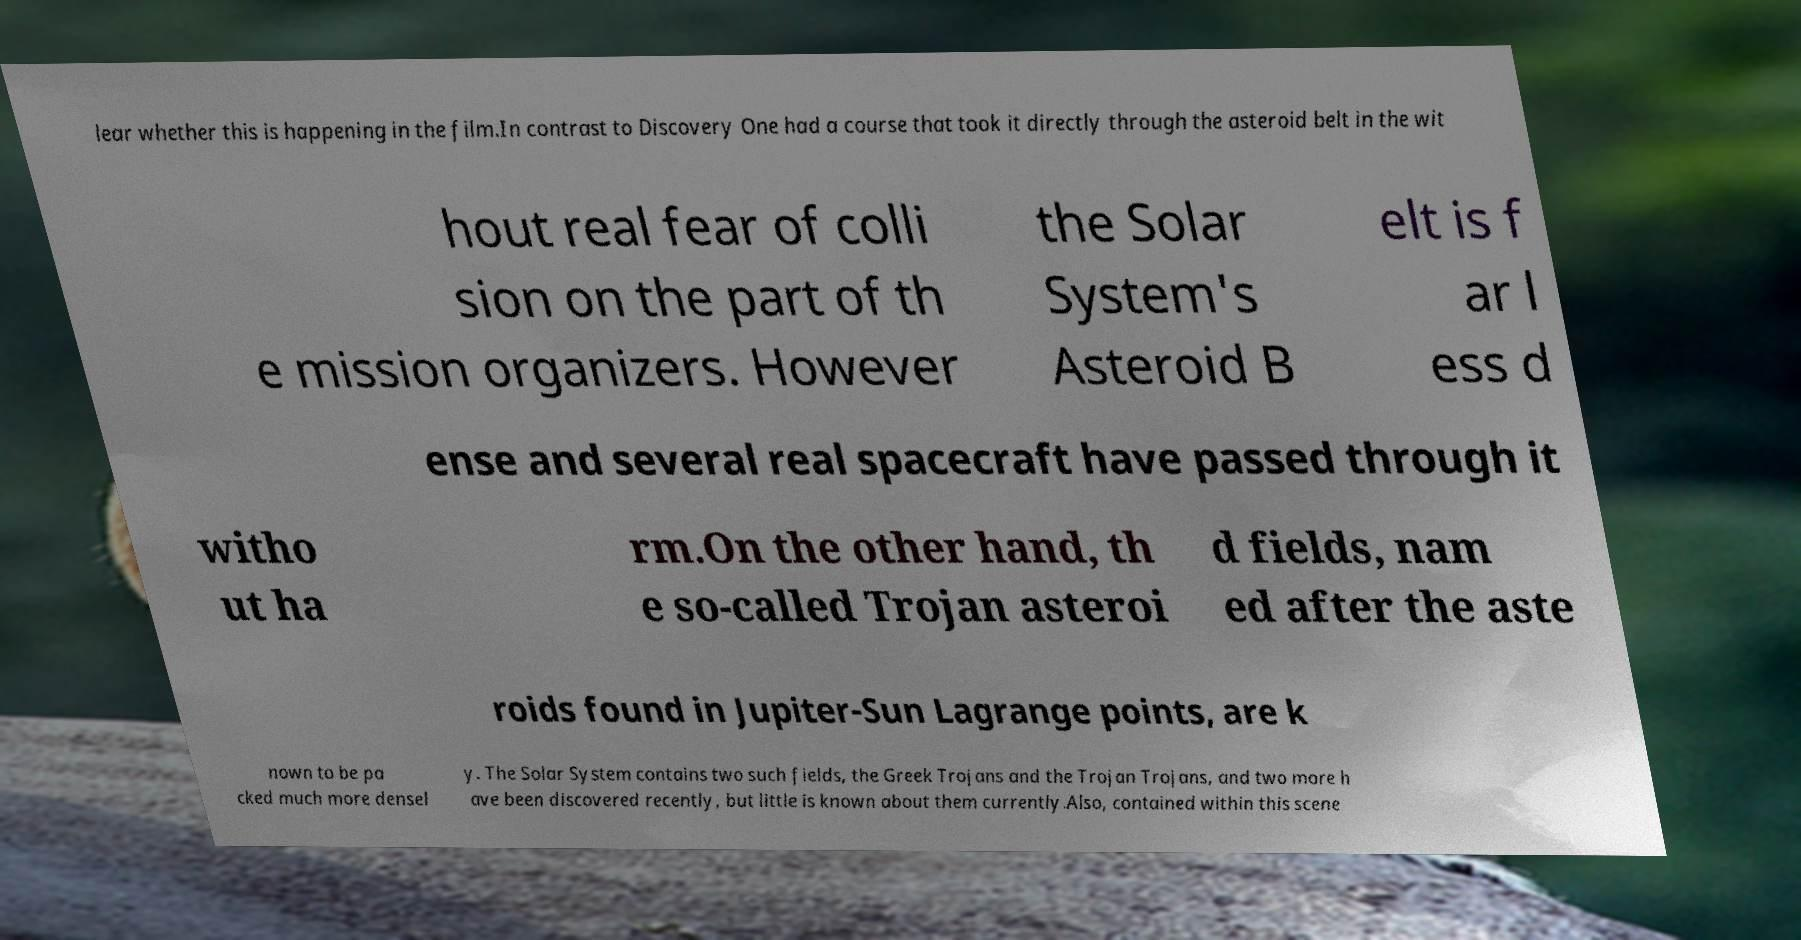Could you assist in decoding the text presented in this image and type it out clearly? lear whether this is happening in the film.In contrast to Discovery One had a course that took it directly through the asteroid belt in the wit hout real fear of colli sion on the part of th e mission organizers. However the Solar System's Asteroid B elt is f ar l ess d ense and several real spacecraft have passed through it witho ut ha rm.On the other hand, th e so-called Trojan asteroi d fields, nam ed after the aste roids found in Jupiter-Sun Lagrange points, are k nown to be pa cked much more densel y. The Solar System contains two such fields, the Greek Trojans and the Trojan Trojans, and two more h ave been discovered recently, but little is known about them currently.Also, contained within this scene 